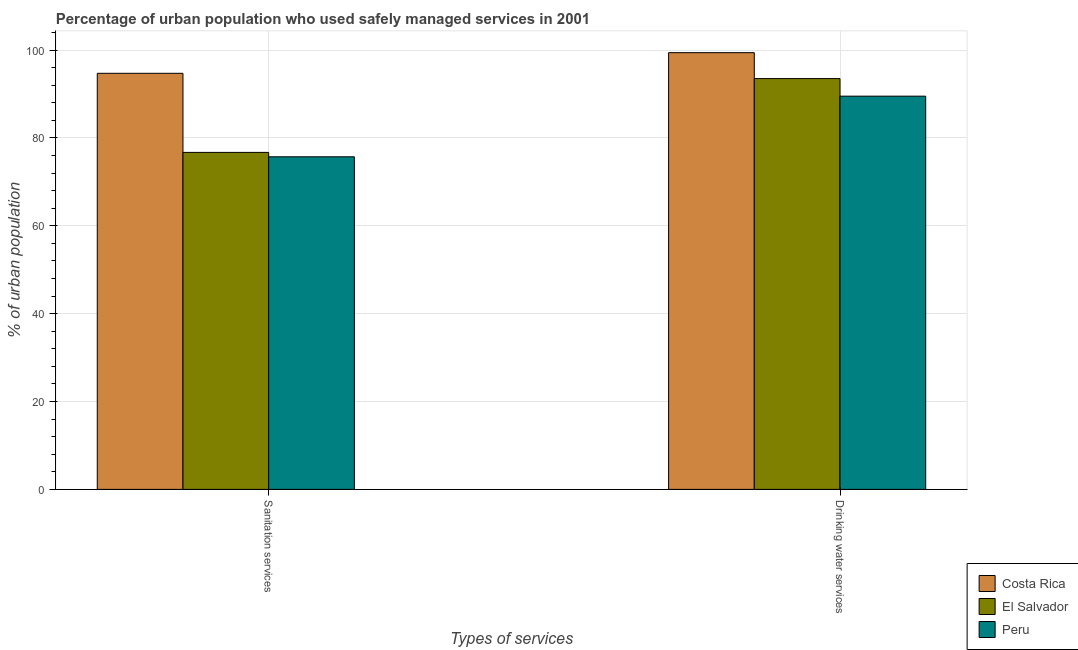Are the number of bars on each tick of the X-axis equal?
Your answer should be compact. Yes. What is the label of the 1st group of bars from the left?
Ensure brevity in your answer.  Sanitation services. What is the percentage of urban population who used drinking water services in El Salvador?
Ensure brevity in your answer.  93.5. Across all countries, what is the maximum percentage of urban population who used drinking water services?
Give a very brief answer. 99.4. Across all countries, what is the minimum percentage of urban population who used drinking water services?
Keep it short and to the point. 89.5. In which country was the percentage of urban population who used sanitation services maximum?
Make the answer very short. Costa Rica. What is the total percentage of urban population who used drinking water services in the graph?
Provide a succinct answer. 282.4. What is the difference between the percentage of urban population who used sanitation services in Costa Rica and the percentage of urban population who used drinking water services in El Salvador?
Provide a short and direct response. 1.2. What is the average percentage of urban population who used sanitation services per country?
Your answer should be compact. 82.37. What is the difference between the percentage of urban population who used sanitation services and percentage of urban population who used drinking water services in Costa Rica?
Give a very brief answer. -4.7. In how many countries, is the percentage of urban population who used sanitation services greater than 4 %?
Offer a terse response. 3. What is the ratio of the percentage of urban population who used drinking water services in El Salvador to that in Peru?
Provide a succinct answer. 1.04. In how many countries, is the percentage of urban population who used sanitation services greater than the average percentage of urban population who used sanitation services taken over all countries?
Provide a succinct answer. 1. What does the 3rd bar from the left in Sanitation services represents?
Offer a terse response. Peru. Are the values on the major ticks of Y-axis written in scientific E-notation?
Make the answer very short. No. Where does the legend appear in the graph?
Give a very brief answer. Bottom right. How many legend labels are there?
Your response must be concise. 3. How are the legend labels stacked?
Provide a short and direct response. Vertical. What is the title of the graph?
Offer a very short reply. Percentage of urban population who used safely managed services in 2001. What is the label or title of the X-axis?
Make the answer very short. Types of services. What is the label or title of the Y-axis?
Your answer should be compact. % of urban population. What is the % of urban population in Costa Rica in Sanitation services?
Provide a short and direct response. 94.7. What is the % of urban population of El Salvador in Sanitation services?
Give a very brief answer. 76.7. What is the % of urban population of Peru in Sanitation services?
Keep it short and to the point. 75.7. What is the % of urban population in Costa Rica in Drinking water services?
Ensure brevity in your answer.  99.4. What is the % of urban population in El Salvador in Drinking water services?
Give a very brief answer. 93.5. What is the % of urban population in Peru in Drinking water services?
Your answer should be compact. 89.5. Across all Types of services, what is the maximum % of urban population of Costa Rica?
Your response must be concise. 99.4. Across all Types of services, what is the maximum % of urban population of El Salvador?
Provide a short and direct response. 93.5. Across all Types of services, what is the maximum % of urban population in Peru?
Your answer should be compact. 89.5. Across all Types of services, what is the minimum % of urban population of Costa Rica?
Ensure brevity in your answer.  94.7. Across all Types of services, what is the minimum % of urban population of El Salvador?
Provide a succinct answer. 76.7. Across all Types of services, what is the minimum % of urban population of Peru?
Make the answer very short. 75.7. What is the total % of urban population of Costa Rica in the graph?
Provide a short and direct response. 194.1. What is the total % of urban population in El Salvador in the graph?
Offer a terse response. 170.2. What is the total % of urban population in Peru in the graph?
Your response must be concise. 165.2. What is the difference between the % of urban population in Costa Rica in Sanitation services and that in Drinking water services?
Keep it short and to the point. -4.7. What is the difference between the % of urban population of El Salvador in Sanitation services and that in Drinking water services?
Ensure brevity in your answer.  -16.8. What is the difference between the % of urban population in Costa Rica in Sanitation services and the % of urban population in El Salvador in Drinking water services?
Give a very brief answer. 1.2. What is the average % of urban population in Costa Rica per Types of services?
Ensure brevity in your answer.  97.05. What is the average % of urban population of El Salvador per Types of services?
Make the answer very short. 85.1. What is the average % of urban population of Peru per Types of services?
Keep it short and to the point. 82.6. What is the difference between the % of urban population of El Salvador and % of urban population of Peru in Sanitation services?
Your answer should be compact. 1. What is the ratio of the % of urban population of Costa Rica in Sanitation services to that in Drinking water services?
Offer a terse response. 0.95. What is the ratio of the % of urban population in El Salvador in Sanitation services to that in Drinking water services?
Give a very brief answer. 0.82. What is the ratio of the % of urban population of Peru in Sanitation services to that in Drinking water services?
Keep it short and to the point. 0.85. What is the difference between the highest and the second highest % of urban population in Costa Rica?
Ensure brevity in your answer.  4.7. What is the difference between the highest and the lowest % of urban population in Costa Rica?
Make the answer very short. 4.7. 